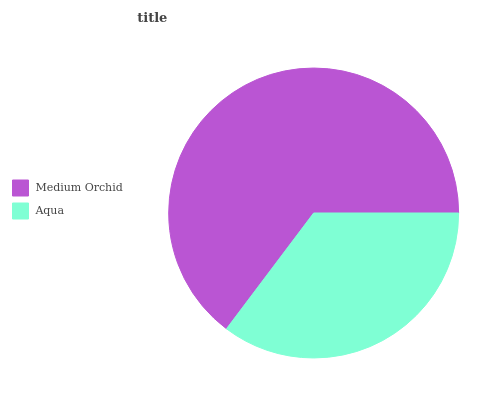Is Aqua the minimum?
Answer yes or no. Yes. Is Medium Orchid the maximum?
Answer yes or no. Yes. Is Aqua the maximum?
Answer yes or no. No. Is Medium Orchid greater than Aqua?
Answer yes or no. Yes. Is Aqua less than Medium Orchid?
Answer yes or no. Yes. Is Aqua greater than Medium Orchid?
Answer yes or no. No. Is Medium Orchid less than Aqua?
Answer yes or no. No. Is Medium Orchid the high median?
Answer yes or no. Yes. Is Aqua the low median?
Answer yes or no. Yes. Is Aqua the high median?
Answer yes or no. No. Is Medium Orchid the low median?
Answer yes or no. No. 